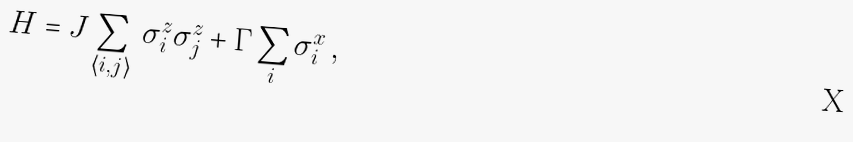Convert formula to latex. <formula><loc_0><loc_0><loc_500><loc_500>H = J \sum _ { \langle i , j \rangle } \, \sigma ^ { z } _ { i } \sigma ^ { z } _ { j } + \Gamma \sum _ { i } \sigma ^ { x } _ { i } \, ,</formula> 